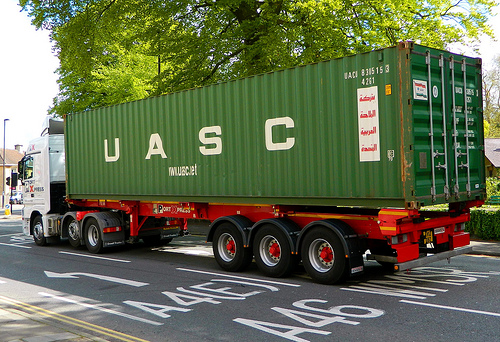What piece of furniture is it? It is a bed. 